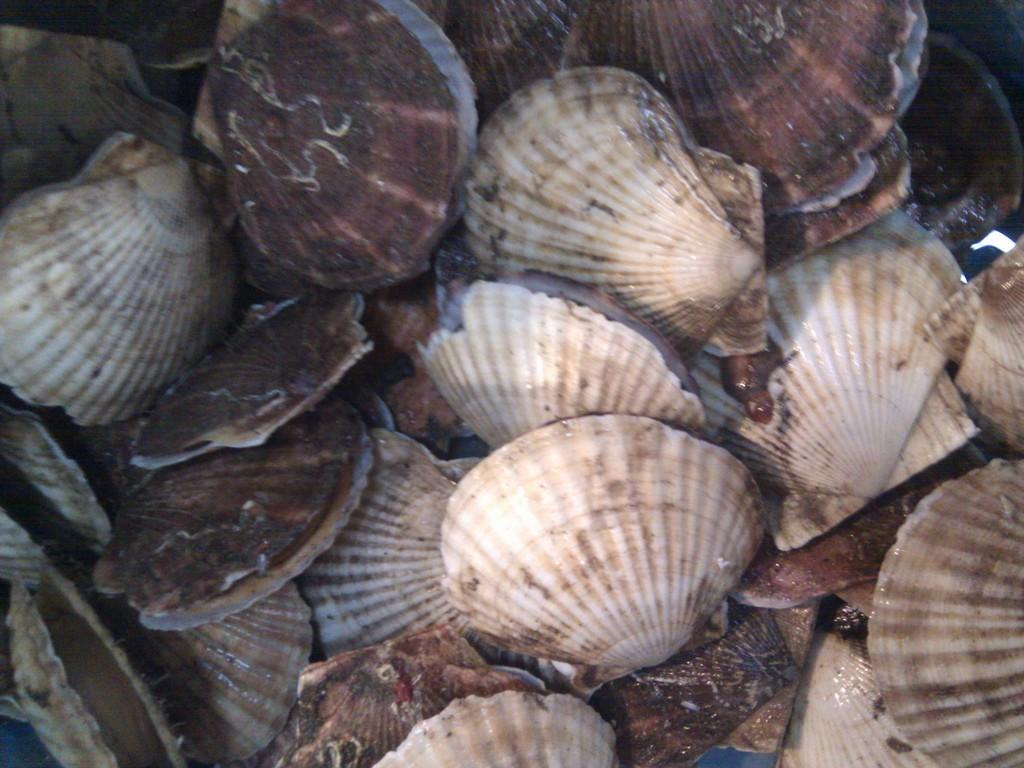What type of objects are present in the image? There are many shells in the image. Can you describe the appearance of the shells? The shells in the image have various shapes, sizes, and colors. Are the shells arranged in any particular pattern or order? The facts provided do not mention any specific arrangement of the shells. What type of weather can be seen in the image? The facts provided do not mention any weather conditions in the image. The image only shows many shells, and there is no indication of weather. 